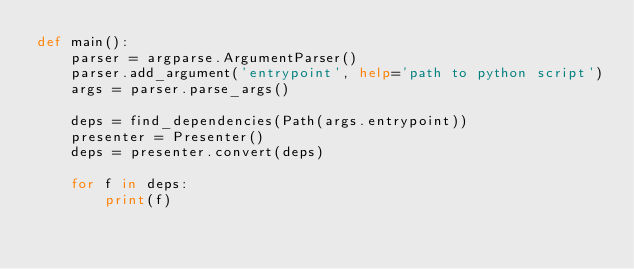<code> <loc_0><loc_0><loc_500><loc_500><_Python_>def main():
    parser = argparse.ArgumentParser()
    parser.add_argument('entrypoint', help='path to python script')
    args = parser.parse_args()

    deps = find_dependencies(Path(args.entrypoint))
    presenter = Presenter()
    deps = presenter.convert(deps)

    for f in deps:
        print(f)
</code> 